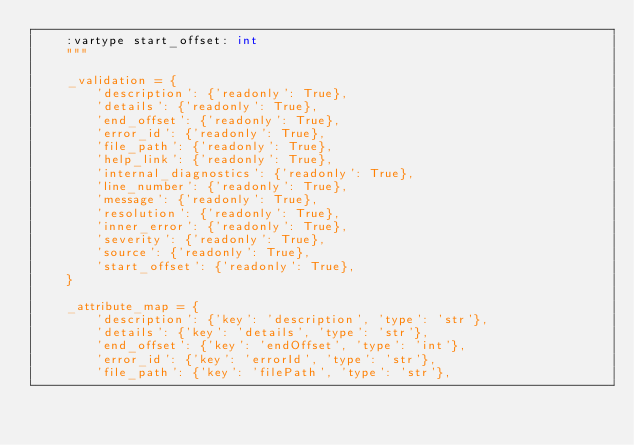<code> <loc_0><loc_0><loc_500><loc_500><_Python_>    :vartype start_offset: int
    """ 

    _validation = {
        'description': {'readonly': True},
        'details': {'readonly': True},
        'end_offset': {'readonly': True},
        'error_id': {'readonly': True},
        'file_path': {'readonly': True},
        'help_link': {'readonly': True},
        'internal_diagnostics': {'readonly': True},
        'line_number': {'readonly': True},
        'message': {'readonly': True},
        'resolution': {'readonly': True},
        'inner_error': {'readonly': True},
        'severity': {'readonly': True},
        'source': {'readonly': True},
        'start_offset': {'readonly': True},
    }

    _attribute_map = {
        'description': {'key': 'description', 'type': 'str'},
        'details': {'key': 'details', 'type': 'str'},
        'end_offset': {'key': 'endOffset', 'type': 'int'},
        'error_id': {'key': 'errorId', 'type': 'str'},
        'file_path': {'key': 'filePath', 'type': 'str'},</code> 